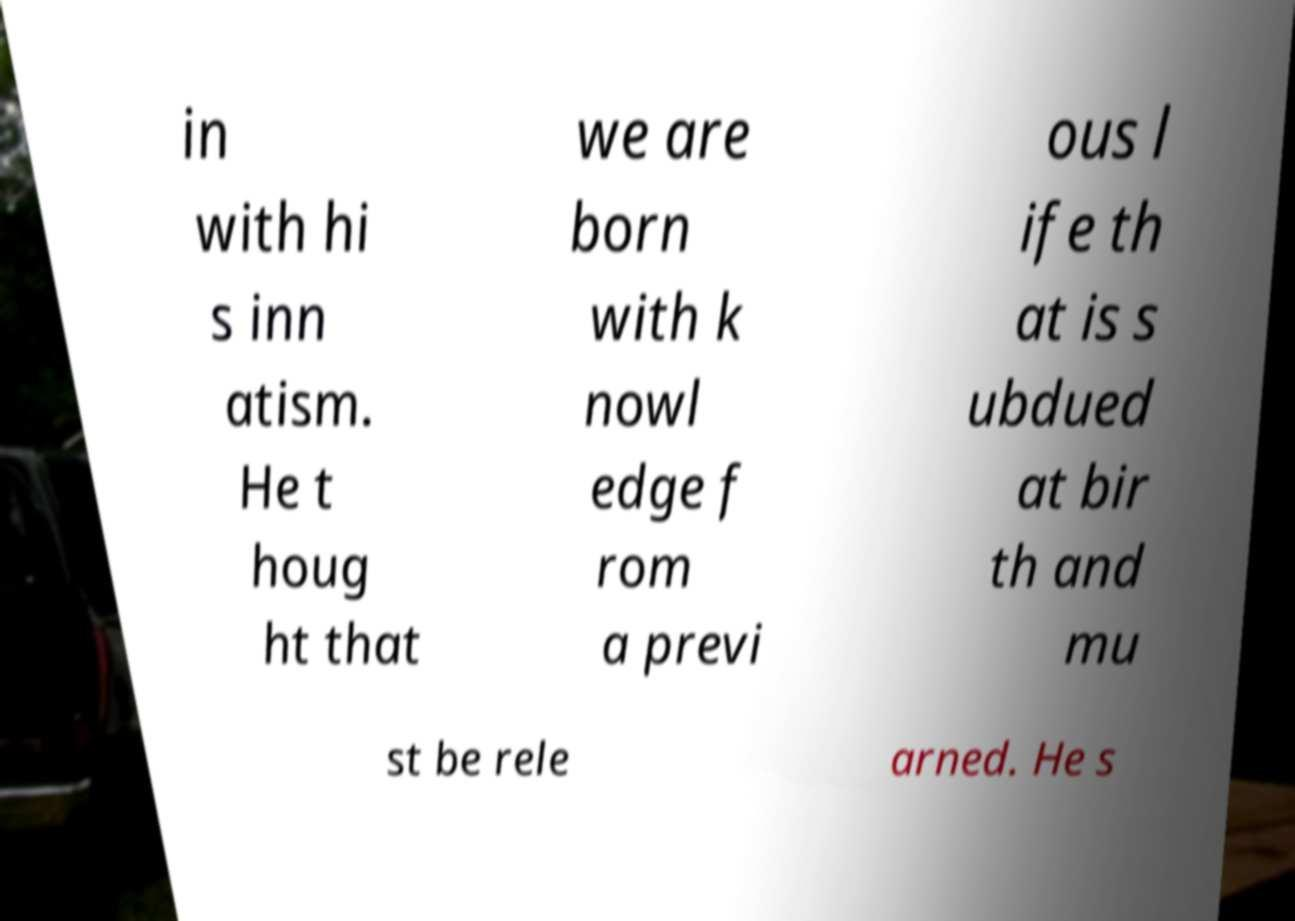Could you extract and type out the text from this image? in with hi s inn atism. He t houg ht that we are born with k nowl edge f rom a previ ous l ife th at is s ubdued at bir th and mu st be rele arned. He s 